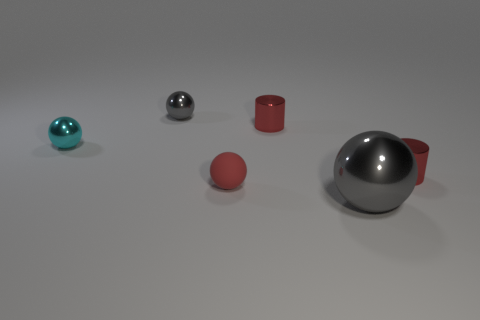Subtract 1 balls. How many balls are left? 3 Subtract all shiny balls. How many balls are left? 1 Add 2 big cyan rubber objects. How many objects exist? 8 Subtract all yellow balls. Subtract all green blocks. How many balls are left? 4 Subtract all balls. How many objects are left? 2 Add 4 red balls. How many red balls are left? 5 Add 4 large shiny spheres. How many large shiny spheres exist? 5 Subtract 0 blue spheres. How many objects are left? 6 Subtract all tiny green metal cubes. Subtract all small things. How many objects are left? 1 